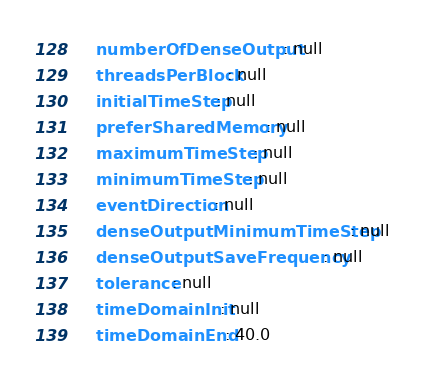Convert code to text. <code><loc_0><loc_0><loc_500><loc_500><_YAML_>    numberOfDenseOutput: null
    threadsPerBlock: null
    initialTimeStep: null
    preferSharedMemory: null
    maximumTimeStep: null
    minimumTimeStep: null
    eventDirection: null
    denseOutputMinimumTimeStep: null
    denseOutputSaveFrequency: null
    tolerance: null
    timeDomainInit: null
    timeDomainEnd: 40.0
</code> 